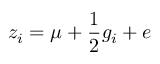<formula> <loc_0><loc_0><loc_500><loc_500>z _ { i } = \mu + { \frac { 1 } { 2 } } g _ { i } + e</formula> 